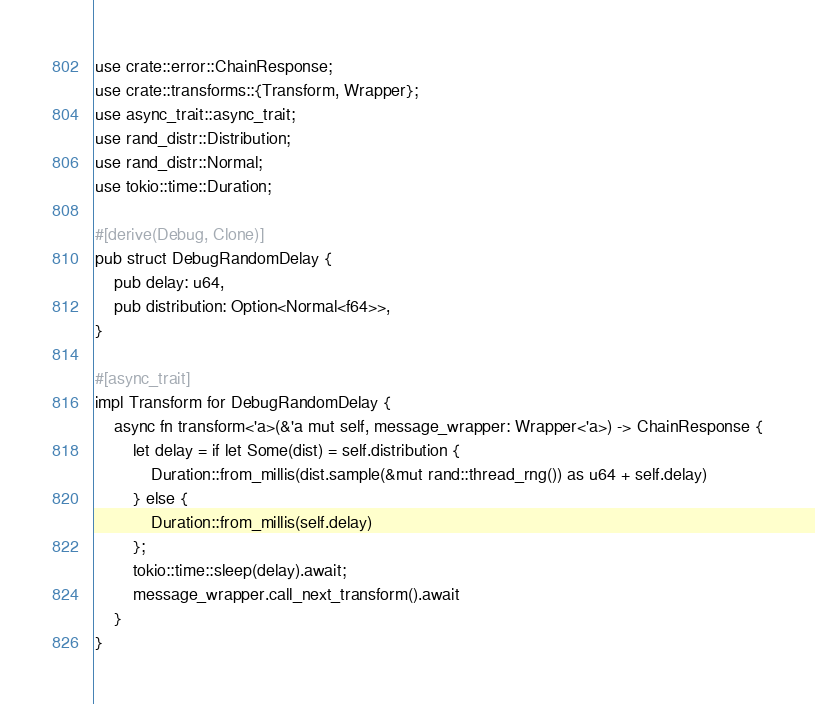<code> <loc_0><loc_0><loc_500><loc_500><_Rust_>use crate::error::ChainResponse;
use crate::transforms::{Transform, Wrapper};
use async_trait::async_trait;
use rand_distr::Distribution;
use rand_distr::Normal;
use tokio::time::Duration;

#[derive(Debug, Clone)]
pub struct DebugRandomDelay {
    pub delay: u64,
    pub distribution: Option<Normal<f64>>,
}

#[async_trait]
impl Transform for DebugRandomDelay {
    async fn transform<'a>(&'a mut self, message_wrapper: Wrapper<'a>) -> ChainResponse {
        let delay = if let Some(dist) = self.distribution {
            Duration::from_millis(dist.sample(&mut rand::thread_rng()) as u64 + self.delay)
        } else {
            Duration::from_millis(self.delay)
        };
        tokio::time::sleep(delay).await;
        message_wrapper.call_next_transform().await
    }
}
</code> 